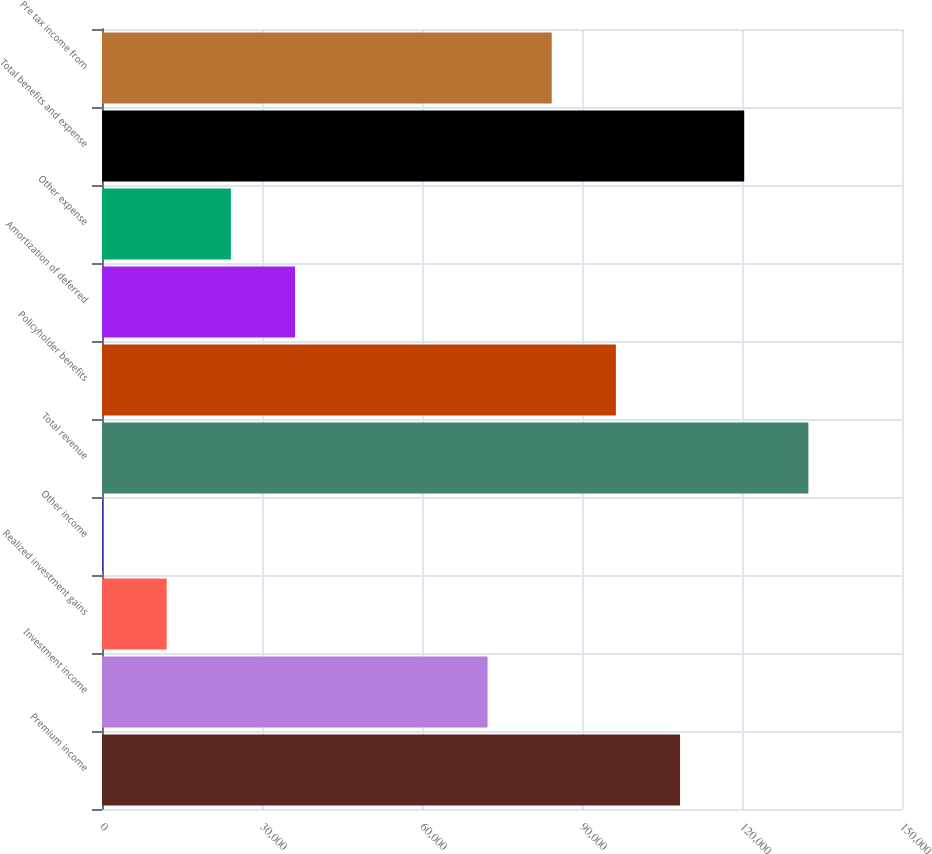<chart> <loc_0><loc_0><loc_500><loc_500><bar_chart><fcel>Premium income<fcel>Investment income<fcel>Realized investment gains<fcel>Other income<fcel>Total revenue<fcel>Policyholder benefits<fcel>Amortization of deferred<fcel>Other expense<fcel>Total benefits and expense<fcel>Pre tax income from<nl><fcel>108384<fcel>72290.2<fcel>12134.2<fcel>103<fcel>132446<fcel>96352.6<fcel>36196.6<fcel>24165.4<fcel>120415<fcel>84321.4<nl></chart> 